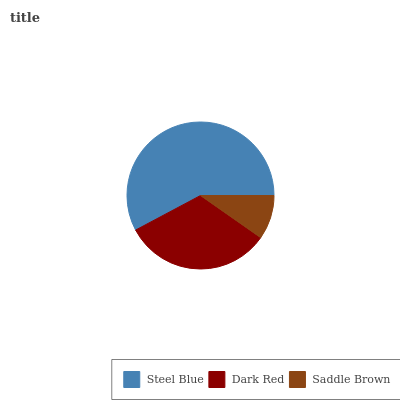Is Saddle Brown the minimum?
Answer yes or no. Yes. Is Steel Blue the maximum?
Answer yes or no. Yes. Is Dark Red the minimum?
Answer yes or no. No. Is Dark Red the maximum?
Answer yes or no. No. Is Steel Blue greater than Dark Red?
Answer yes or no. Yes. Is Dark Red less than Steel Blue?
Answer yes or no. Yes. Is Dark Red greater than Steel Blue?
Answer yes or no. No. Is Steel Blue less than Dark Red?
Answer yes or no. No. Is Dark Red the high median?
Answer yes or no. Yes. Is Dark Red the low median?
Answer yes or no. Yes. Is Steel Blue the high median?
Answer yes or no. No. Is Saddle Brown the low median?
Answer yes or no. No. 